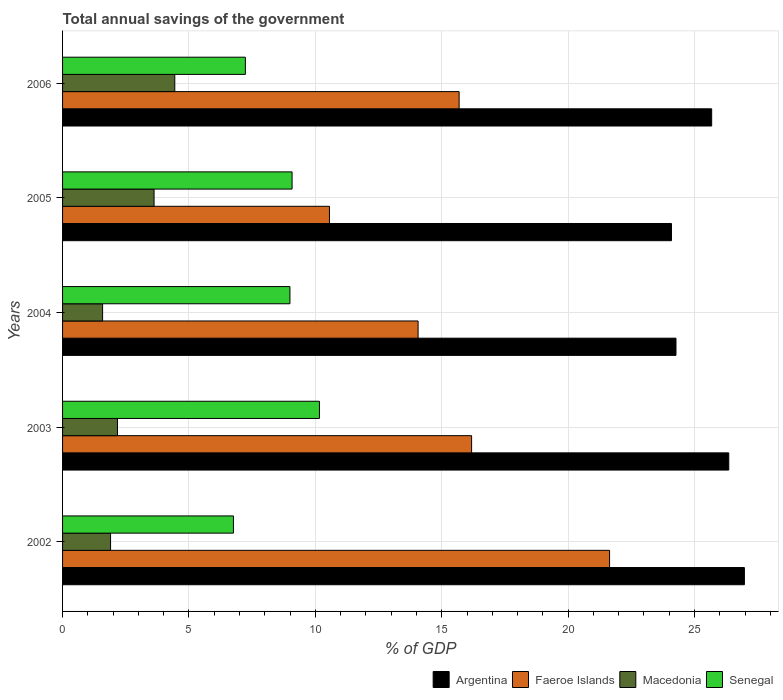Are the number of bars per tick equal to the number of legend labels?
Provide a succinct answer. Yes. How many bars are there on the 2nd tick from the bottom?
Your response must be concise. 4. What is the label of the 5th group of bars from the top?
Provide a short and direct response. 2002. What is the total annual savings of the government in Argentina in 2004?
Offer a terse response. 24.27. Across all years, what is the maximum total annual savings of the government in Senegal?
Provide a succinct answer. 10.16. Across all years, what is the minimum total annual savings of the government in Macedonia?
Ensure brevity in your answer.  1.58. What is the total total annual savings of the government in Macedonia in the graph?
Give a very brief answer. 13.71. What is the difference between the total annual savings of the government in Macedonia in 2004 and that in 2005?
Your response must be concise. -2.04. What is the difference between the total annual savings of the government in Senegal in 2003 and the total annual savings of the government in Argentina in 2002?
Provide a succinct answer. -16.81. What is the average total annual savings of the government in Argentina per year?
Give a very brief answer. 25.47. In the year 2004, what is the difference between the total annual savings of the government in Faeroe Islands and total annual savings of the government in Senegal?
Your answer should be compact. 5.07. In how many years, is the total annual savings of the government in Faeroe Islands greater than 11 %?
Provide a short and direct response. 4. What is the ratio of the total annual savings of the government in Macedonia in 2003 to that in 2005?
Give a very brief answer. 0.6. Is the total annual savings of the government in Macedonia in 2003 less than that in 2004?
Give a very brief answer. No. What is the difference between the highest and the second highest total annual savings of the government in Argentina?
Provide a succinct answer. 0.62. What is the difference between the highest and the lowest total annual savings of the government in Senegal?
Provide a succinct answer. 3.4. In how many years, is the total annual savings of the government in Macedonia greater than the average total annual savings of the government in Macedonia taken over all years?
Provide a short and direct response. 2. Is the sum of the total annual savings of the government in Argentina in 2004 and 2006 greater than the maximum total annual savings of the government in Faeroe Islands across all years?
Offer a terse response. Yes. Is it the case that in every year, the sum of the total annual savings of the government in Faeroe Islands and total annual savings of the government in Macedonia is greater than the sum of total annual savings of the government in Senegal and total annual savings of the government in Argentina?
Keep it short and to the point. No. What does the 3rd bar from the top in 2006 represents?
Provide a succinct answer. Faeroe Islands. What is the difference between two consecutive major ticks on the X-axis?
Give a very brief answer. 5. Are the values on the major ticks of X-axis written in scientific E-notation?
Your answer should be compact. No. Does the graph contain any zero values?
Give a very brief answer. No. Where does the legend appear in the graph?
Offer a terse response. Bottom right. What is the title of the graph?
Keep it short and to the point. Total annual savings of the government. Does "Germany" appear as one of the legend labels in the graph?
Provide a succinct answer. No. What is the label or title of the X-axis?
Offer a very short reply. % of GDP. What is the label or title of the Y-axis?
Your response must be concise. Years. What is the % of GDP of Argentina in 2002?
Your answer should be very brief. 26.97. What is the % of GDP in Faeroe Islands in 2002?
Offer a very short reply. 21.64. What is the % of GDP in Macedonia in 2002?
Give a very brief answer. 1.9. What is the % of GDP in Senegal in 2002?
Your answer should be very brief. 6.76. What is the % of GDP in Argentina in 2003?
Offer a terse response. 26.35. What is the % of GDP in Faeroe Islands in 2003?
Your answer should be compact. 16.18. What is the % of GDP of Macedonia in 2003?
Your answer should be compact. 2.17. What is the % of GDP of Senegal in 2003?
Offer a very short reply. 10.16. What is the % of GDP of Argentina in 2004?
Keep it short and to the point. 24.27. What is the % of GDP of Faeroe Islands in 2004?
Provide a succinct answer. 14.06. What is the % of GDP of Macedonia in 2004?
Offer a very short reply. 1.58. What is the % of GDP in Senegal in 2004?
Your response must be concise. 8.99. What is the % of GDP of Argentina in 2005?
Offer a very short reply. 24.09. What is the % of GDP in Faeroe Islands in 2005?
Make the answer very short. 10.56. What is the % of GDP in Macedonia in 2005?
Offer a very short reply. 3.62. What is the % of GDP of Senegal in 2005?
Provide a short and direct response. 9.08. What is the % of GDP of Argentina in 2006?
Ensure brevity in your answer.  25.68. What is the % of GDP in Faeroe Islands in 2006?
Offer a very short reply. 15.69. What is the % of GDP of Macedonia in 2006?
Ensure brevity in your answer.  4.44. What is the % of GDP in Senegal in 2006?
Your answer should be compact. 7.23. Across all years, what is the maximum % of GDP in Argentina?
Make the answer very short. 26.97. Across all years, what is the maximum % of GDP in Faeroe Islands?
Offer a very short reply. 21.64. Across all years, what is the maximum % of GDP in Macedonia?
Offer a very short reply. 4.44. Across all years, what is the maximum % of GDP of Senegal?
Make the answer very short. 10.16. Across all years, what is the minimum % of GDP in Argentina?
Your answer should be very brief. 24.09. Across all years, what is the minimum % of GDP in Faeroe Islands?
Provide a succinct answer. 10.56. Across all years, what is the minimum % of GDP of Macedonia?
Ensure brevity in your answer.  1.58. Across all years, what is the minimum % of GDP of Senegal?
Provide a succinct answer. 6.76. What is the total % of GDP in Argentina in the graph?
Make the answer very short. 127.36. What is the total % of GDP in Faeroe Islands in the graph?
Provide a succinct answer. 78.13. What is the total % of GDP in Macedonia in the graph?
Provide a short and direct response. 13.71. What is the total % of GDP of Senegal in the graph?
Make the answer very short. 42.23. What is the difference between the % of GDP in Argentina in 2002 and that in 2003?
Provide a succinct answer. 0.62. What is the difference between the % of GDP in Faeroe Islands in 2002 and that in 2003?
Offer a very short reply. 5.46. What is the difference between the % of GDP of Macedonia in 2002 and that in 2003?
Your answer should be compact. -0.27. What is the difference between the % of GDP of Senegal in 2002 and that in 2003?
Your answer should be compact. -3.4. What is the difference between the % of GDP of Argentina in 2002 and that in 2004?
Offer a very short reply. 2.71. What is the difference between the % of GDP in Faeroe Islands in 2002 and that in 2004?
Offer a very short reply. 7.57. What is the difference between the % of GDP in Macedonia in 2002 and that in 2004?
Ensure brevity in your answer.  0.32. What is the difference between the % of GDP of Senegal in 2002 and that in 2004?
Give a very brief answer. -2.24. What is the difference between the % of GDP in Argentina in 2002 and that in 2005?
Give a very brief answer. 2.88. What is the difference between the % of GDP of Faeroe Islands in 2002 and that in 2005?
Your answer should be compact. 11.08. What is the difference between the % of GDP of Macedonia in 2002 and that in 2005?
Keep it short and to the point. -1.72. What is the difference between the % of GDP in Senegal in 2002 and that in 2005?
Your response must be concise. -2.32. What is the difference between the % of GDP of Argentina in 2002 and that in 2006?
Give a very brief answer. 1.29. What is the difference between the % of GDP in Faeroe Islands in 2002 and that in 2006?
Ensure brevity in your answer.  5.95. What is the difference between the % of GDP in Macedonia in 2002 and that in 2006?
Your response must be concise. -2.54. What is the difference between the % of GDP in Senegal in 2002 and that in 2006?
Offer a terse response. -0.47. What is the difference between the % of GDP of Argentina in 2003 and that in 2004?
Provide a succinct answer. 2.09. What is the difference between the % of GDP in Faeroe Islands in 2003 and that in 2004?
Your answer should be very brief. 2.12. What is the difference between the % of GDP of Macedonia in 2003 and that in 2004?
Your answer should be very brief. 0.59. What is the difference between the % of GDP in Senegal in 2003 and that in 2004?
Make the answer very short. 1.17. What is the difference between the % of GDP in Argentina in 2003 and that in 2005?
Your answer should be compact. 2.27. What is the difference between the % of GDP in Faeroe Islands in 2003 and that in 2005?
Give a very brief answer. 5.62. What is the difference between the % of GDP of Macedonia in 2003 and that in 2005?
Provide a short and direct response. -1.45. What is the difference between the % of GDP in Senegal in 2003 and that in 2005?
Keep it short and to the point. 1.08. What is the difference between the % of GDP in Argentina in 2003 and that in 2006?
Your response must be concise. 0.68. What is the difference between the % of GDP in Faeroe Islands in 2003 and that in 2006?
Your answer should be very brief. 0.49. What is the difference between the % of GDP of Macedonia in 2003 and that in 2006?
Ensure brevity in your answer.  -2.27. What is the difference between the % of GDP in Senegal in 2003 and that in 2006?
Give a very brief answer. 2.93. What is the difference between the % of GDP of Argentina in 2004 and that in 2005?
Offer a terse response. 0.18. What is the difference between the % of GDP of Faeroe Islands in 2004 and that in 2005?
Provide a succinct answer. 3.51. What is the difference between the % of GDP in Macedonia in 2004 and that in 2005?
Your answer should be very brief. -2.04. What is the difference between the % of GDP of Senegal in 2004 and that in 2005?
Give a very brief answer. -0.08. What is the difference between the % of GDP of Argentina in 2004 and that in 2006?
Your answer should be very brief. -1.41. What is the difference between the % of GDP in Faeroe Islands in 2004 and that in 2006?
Offer a very short reply. -1.62. What is the difference between the % of GDP in Macedonia in 2004 and that in 2006?
Provide a succinct answer. -2.86. What is the difference between the % of GDP in Senegal in 2004 and that in 2006?
Keep it short and to the point. 1.76. What is the difference between the % of GDP of Argentina in 2005 and that in 2006?
Offer a terse response. -1.59. What is the difference between the % of GDP of Faeroe Islands in 2005 and that in 2006?
Offer a terse response. -5.13. What is the difference between the % of GDP in Macedonia in 2005 and that in 2006?
Keep it short and to the point. -0.82. What is the difference between the % of GDP in Senegal in 2005 and that in 2006?
Offer a terse response. 1.85. What is the difference between the % of GDP in Argentina in 2002 and the % of GDP in Faeroe Islands in 2003?
Ensure brevity in your answer.  10.79. What is the difference between the % of GDP in Argentina in 2002 and the % of GDP in Macedonia in 2003?
Keep it short and to the point. 24.8. What is the difference between the % of GDP of Argentina in 2002 and the % of GDP of Senegal in 2003?
Ensure brevity in your answer.  16.81. What is the difference between the % of GDP in Faeroe Islands in 2002 and the % of GDP in Macedonia in 2003?
Provide a short and direct response. 19.47. What is the difference between the % of GDP of Faeroe Islands in 2002 and the % of GDP of Senegal in 2003?
Offer a terse response. 11.48. What is the difference between the % of GDP in Macedonia in 2002 and the % of GDP in Senegal in 2003?
Keep it short and to the point. -8.26. What is the difference between the % of GDP of Argentina in 2002 and the % of GDP of Faeroe Islands in 2004?
Keep it short and to the point. 12.91. What is the difference between the % of GDP in Argentina in 2002 and the % of GDP in Macedonia in 2004?
Your response must be concise. 25.39. What is the difference between the % of GDP in Argentina in 2002 and the % of GDP in Senegal in 2004?
Offer a terse response. 17.98. What is the difference between the % of GDP in Faeroe Islands in 2002 and the % of GDP in Macedonia in 2004?
Offer a very short reply. 20.06. What is the difference between the % of GDP in Faeroe Islands in 2002 and the % of GDP in Senegal in 2004?
Your response must be concise. 12.64. What is the difference between the % of GDP in Macedonia in 2002 and the % of GDP in Senegal in 2004?
Provide a succinct answer. -7.1. What is the difference between the % of GDP in Argentina in 2002 and the % of GDP in Faeroe Islands in 2005?
Ensure brevity in your answer.  16.41. What is the difference between the % of GDP of Argentina in 2002 and the % of GDP of Macedonia in 2005?
Your answer should be very brief. 23.35. What is the difference between the % of GDP of Argentina in 2002 and the % of GDP of Senegal in 2005?
Offer a very short reply. 17.89. What is the difference between the % of GDP of Faeroe Islands in 2002 and the % of GDP of Macedonia in 2005?
Offer a very short reply. 18.02. What is the difference between the % of GDP in Faeroe Islands in 2002 and the % of GDP in Senegal in 2005?
Offer a terse response. 12.56. What is the difference between the % of GDP in Macedonia in 2002 and the % of GDP in Senegal in 2005?
Your answer should be very brief. -7.18. What is the difference between the % of GDP of Argentina in 2002 and the % of GDP of Faeroe Islands in 2006?
Your answer should be compact. 11.29. What is the difference between the % of GDP in Argentina in 2002 and the % of GDP in Macedonia in 2006?
Keep it short and to the point. 22.53. What is the difference between the % of GDP in Argentina in 2002 and the % of GDP in Senegal in 2006?
Provide a short and direct response. 19.74. What is the difference between the % of GDP of Faeroe Islands in 2002 and the % of GDP of Macedonia in 2006?
Provide a short and direct response. 17.2. What is the difference between the % of GDP of Faeroe Islands in 2002 and the % of GDP of Senegal in 2006?
Ensure brevity in your answer.  14.41. What is the difference between the % of GDP in Macedonia in 2002 and the % of GDP in Senegal in 2006?
Provide a succinct answer. -5.33. What is the difference between the % of GDP in Argentina in 2003 and the % of GDP in Faeroe Islands in 2004?
Your answer should be compact. 12.29. What is the difference between the % of GDP in Argentina in 2003 and the % of GDP in Macedonia in 2004?
Provide a succinct answer. 24.77. What is the difference between the % of GDP in Argentina in 2003 and the % of GDP in Senegal in 2004?
Your response must be concise. 17.36. What is the difference between the % of GDP of Faeroe Islands in 2003 and the % of GDP of Macedonia in 2004?
Your answer should be compact. 14.6. What is the difference between the % of GDP in Faeroe Islands in 2003 and the % of GDP in Senegal in 2004?
Your answer should be very brief. 7.19. What is the difference between the % of GDP in Macedonia in 2003 and the % of GDP in Senegal in 2004?
Make the answer very short. -6.82. What is the difference between the % of GDP in Argentina in 2003 and the % of GDP in Faeroe Islands in 2005?
Ensure brevity in your answer.  15.8. What is the difference between the % of GDP of Argentina in 2003 and the % of GDP of Macedonia in 2005?
Offer a very short reply. 22.74. What is the difference between the % of GDP of Argentina in 2003 and the % of GDP of Senegal in 2005?
Provide a short and direct response. 17.28. What is the difference between the % of GDP of Faeroe Islands in 2003 and the % of GDP of Macedonia in 2005?
Provide a short and direct response. 12.56. What is the difference between the % of GDP of Faeroe Islands in 2003 and the % of GDP of Senegal in 2005?
Your answer should be very brief. 7.1. What is the difference between the % of GDP of Macedonia in 2003 and the % of GDP of Senegal in 2005?
Provide a succinct answer. -6.91. What is the difference between the % of GDP in Argentina in 2003 and the % of GDP in Faeroe Islands in 2006?
Provide a short and direct response. 10.67. What is the difference between the % of GDP in Argentina in 2003 and the % of GDP in Macedonia in 2006?
Provide a short and direct response. 21.92. What is the difference between the % of GDP of Argentina in 2003 and the % of GDP of Senegal in 2006?
Your answer should be compact. 19.12. What is the difference between the % of GDP in Faeroe Islands in 2003 and the % of GDP in Macedonia in 2006?
Your response must be concise. 11.74. What is the difference between the % of GDP of Faeroe Islands in 2003 and the % of GDP of Senegal in 2006?
Your answer should be very brief. 8.95. What is the difference between the % of GDP in Macedonia in 2003 and the % of GDP in Senegal in 2006?
Provide a short and direct response. -5.06. What is the difference between the % of GDP of Argentina in 2004 and the % of GDP of Faeroe Islands in 2005?
Make the answer very short. 13.71. What is the difference between the % of GDP of Argentina in 2004 and the % of GDP of Macedonia in 2005?
Ensure brevity in your answer.  20.65. What is the difference between the % of GDP of Argentina in 2004 and the % of GDP of Senegal in 2005?
Make the answer very short. 15.19. What is the difference between the % of GDP of Faeroe Islands in 2004 and the % of GDP of Macedonia in 2005?
Your answer should be very brief. 10.45. What is the difference between the % of GDP of Faeroe Islands in 2004 and the % of GDP of Senegal in 2005?
Make the answer very short. 4.99. What is the difference between the % of GDP in Macedonia in 2004 and the % of GDP in Senegal in 2005?
Offer a very short reply. -7.5. What is the difference between the % of GDP in Argentina in 2004 and the % of GDP in Faeroe Islands in 2006?
Keep it short and to the point. 8.58. What is the difference between the % of GDP in Argentina in 2004 and the % of GDP in Macedonia in 2006?
Provide a succinct answer. 19.83. What is the difference between the % of GDP of Argentina in 2004 and the % of GDP of Senegal in 2006?
Ensure brevity in your answer.  17.03. What is the difference between the % of GDP of Faeroe Islands in 2004 and the % of GDP of Macedonia in 2006?
Your answer should be compact. 9.63. What is the difference between the % of GDP of Faeroe Islands in 2004 and the % of GDP of Senegal in 2006?
Your response must be concise. 6.83. What is the difference between the % of GDP of Macedonia in 2004 and the % of GDP of Senegal in 2006?
Offer a very short reply. -5.65. What is the difference between the % of GDP in Argentina in 2005 and the % of GDP in Faeroe Islands in 2006?
Offer a very short reply. 8.4. What is the difference between the % of GDP in Argentina in 2005 and the % of GDP in Macedonia in 2006?
Your response must be concise. 19.65. What is the difference between the % of GDP of Argentina in 2005 and the % of GDP of Senegal in 2006?
Keep it short and to the point. 16.86. What is the difference between the % of GDP in Faeroe Islands in 2005 and the % of GDP in Macedonia in 2006?
Give a very brief answer. 6.12. What is the difference between the % of GDP of Faeroe Islands in 2005 and the % of GDP of Senegal in 2006?
Make the answer very short. 3.33. What is the difference between the % of GDP of Macedonia in 2005 and the % of GDP of Senegal in 2006?
Your answer should be compact. -3.61. What is the average % of GDP of Argentina per year?
Provide a succinct answer. 25.47. What is the average % of GDP of Faeroe Islands per year?
Give a very brief answer. 15.63. What is the average % of GDP of Macedonia per year?
Your answer should be compact. 2.74. What is the average % of GDP of Senegal per year?
Your answer should be compact. 8.45. In the year 2002, what is the difference between the % of GDP in Argentina and % of GDP in Faeroe Islands?
Offer a very short reply. 5.33. In the year 2002, what is the difference between the % of GDP in Argentina and % of GDP in Macedonia?
Make the answer very short. 25.07. In the year 2002, what is the difference between the % of GDP of Argentina and % of GDP of Senegal?
Offer a very short reply. 20.21. In the year 2002, what is the difference between the % of GDP in Faeroe Islands and % of GDP in Macedonia?
Give a very brief answer. 19.74. In the year 2002, what is the difference between the % of GDP in Faeroe Islands and % of GDP in Senegal?
Offer a terse response. 14.88. In the year 2002, what is the difference between the % of GDP of Macedonia and % of GDP of Senegal?
Ensure brevity in your answer.  -4.86. In the year 2003, what is the difference between the % of GDP in Argentina and % of GDP in Faeroe Islands?
Ensure brevity in your answer.  10.17. In the year 2003, what is the difference between the % of GDP in Argentina and % of GDP in Macedonia?
Your response must be concise. 24.18. In the year 2003, what is the difference between the % of GDP in Argentina and % of GDP in Senegal?
Your answer should be compact. 16.19. In the year 2003, what is the difference between the % of GDP of Faeroe Islands and % of GDP of Macedonia?
Provide a short and direct response. 14.01. In the year 2003, what is the difference between the % of GDP in Faeroe Islands and % of GDP in Senegal?
Offer a very short reply. 6.02. In the year 2003, what is the difference between the % of GDP of Macedonia and % of GDP of Senegal?
Your answer should be very brief. -7.99. In the year 2004, what is the difference between the % of GDP of Argentina and % of GDP of Faeroe Islands?
Offer a very short reply. 10.2. In the year 2004, what is the difference between the % of GDP of Argentina and % of GDP of Macedonia?
Ensure brevity in your answer.  22.68. In the year 2004, what is the difference between the % of GDP in Argentina and % of GDP in Senegal?
Provide a short and direct response. 15.27. In the year 2004, what is the difference between the % of GDP in Faeroe Islands and % of GDP in Macedonia?
Give a very brief answer. 12.48. In the year 2004, what is the difference between the % of GDP in Faeroe Islands and % of GDP in Senegal?
Your answer should be compact. 5.07. In the year 2004, what is the difference between the % of GDP in Macedonia and % of GDP in Senegal?
Your answer should be compact. -7.41. In the year 2005, what is the difference between the % of GDP of Argentina and % of GDP of Faeroe Islands?
Provide a short and direct response. 13.53. In the year 2005, what is the difference between the % of GDP in Argentina and % of GDP in Macedonia?
Your response must be concise. 20.47. In the year 2005, what is the difference between the % of GDP in Argentina and % of GDP in Senegal?
Your answer should be very brief. 15.01. In the year 2005, what is the difference between the % of GDP of Faeroe Islands and % of GDP of Macedonia?
Your response must be concise. 6.94. In the year 2005, what is the difference between the % of GDP in Faeroe Islands and % of GDP in Senegal?
Offer a terse response. 1.48. In the year 2005, what is the difference between the % of GDP in Macedonia and % of GDP in Senegal?
Provide a short and direct response. -5.46. In the year 2006, what is the difference between the % of GDP of Argentina and % of GDP of Faeroe Islands?
Provide a succinct answer. 9.99. In the year 2006, what is the difference between the % of GDP in Argentina and % of GDP in Macedonia?
Provide a succinct answer. 21.24. In the year 2006, what is the difference between the % of GDP of Argentina and % of GDP of Senegal?
Keep it short and to the point. 18.45. In the year 2006, what is the difference between the % of GDP in Faeroe Islands and % of GDP in Macedonia?
Offer a very short reply. 11.25. In the year 2006, what is the difference between the % of GDP in Faeroe Islands and % of GDP in Senegal?
Give a very brief answer. 8.46. In the year 2006, what is the difference between the % of GDP in Macedonia and % of GDP in Senegal?
Provide a succinct answer. -2.79. What is the ratio of the % of GDP in Argentina in 2002 to that in 2003?
Offer a very short reply. 1.02. What is the ratio of the % of GDP of Faeroe Islands in 2002 to that in 2003?
Provide a short and direct response. 1.34. What is the ratio of the % of GDP of Macedonia in 2002 to that in 2003?
Give a very brief answer. 0.87. What is the ratio of the % of GDP in Senegal in 2002 to that in 2003?
Give a very brief answer. 0.67. What is the ratio of the % of GDP in Argentina in 2002 to that in 2004?
Provide a short and direct response. 1.11. What is the ratio of the % of GDP of Faeroe Islands in 2002 to that in 2004?
Make the answer very short. 1.54. What is the ratio of the % of GDP in Macedonia in 2002 to that in 2004?
Your response must be concise. 1.2. What is the ratio of the % of GDP in Senegal in 2002 to that in 2004?
Make the answer very short. 0.75. What is the ratio of the % of GDP in Argentina in 2002 to that in 2005?
Give a very brief answer. 1.12. What is the ratio of the % of GDP in Faeroe Islands in 2002 to that in 2005?
Provide a succinct answer. 2.05. What is the ratio of the % of GDP of Macedonia in 2002 to that in 2005?
Keep it short and to the point. 0.52. What is the ratio of the % of GDP in Senegal in 2002 to that in 2005?
Offer a very short reply. 0.74. What is the ratio of the % of GDP in Argentina in 2002 to that in 2006?
Your answer should be very brief. 1.05. What is the ratio of the % of GDP in Faeroe Islands in 2002 to that in 2006?
Your answer should be compact. 1.38. What is the ratio of the % of GDP in Macedonia in 2002 to that in 2006?
Your answer should be very brief. 0.43. What is the ratio of the % of GDP of Senegal in 2002 to that in 2006?
Provide a succinct answer. 0.93. What is the ratio of the % of GDP in Argentina in 2003 to that in 2004?
Ensure brevity in your answer.  1.09. What is the ratio of the % of GDP of Faeroe Islands in 2003 to that in 2004?
Your answer should be compact. 1.15. What is the ratio of the % of GDP of Macedonia in 2003 to that in 2004?
Provide a short and direct response. 1.37. What is the ratio of the % of GDP in Senegal in 2003 to that in 2004?
Give a very brief answer. 1.13. What is the ratio of the % of GDP in Argentina in 2003 to that in 2005?
Give a very brief answer. 1.09. What is the ratio of the % of GDP of Faeroe Islands in 2003 to that in 2005?
Your answer should be very brief. 1.53. What is the ratio of the % of GDP of Macedonia in 2003 to that in 2005?
Give a very brief answer. 0.6. What is the ratio of the % of GDP in Senegal in 2003 to that in 2005?
Ensure brevity in your answer.  1.12. What is the ratio of the % of GDP in Argentina in 2003 to that in 2006?
Your answer should be very brief. 1.03. What is the ratio of the % of GDP of Faeroe Islands in 2003 to that in 2006?
Give a very brief answer. 1.03. What is the ratio of the % of GDP of Macedonia in 2003 to that in 2006?
Your response must be concise. 0.49. What is the ratio of the % of GDP in Senegal in 2003 to that in 2006?
Provide a short and direct response. 1.41. What is the ratio of the % of GDP of Argentina in 2004 to that in 2005?
Offer a very short reply. 1.01. What is the ratio of the % of GDP in Faeroe Islands in 2004 to that in 2005?
Your response must be concise. 1.33. What is the ratio of the % of GDP in Macedonia in 2004 to that in 2005?
Your answer should be very brief. 0.44. What is the ratio of the % of GDP of Argentina in 2004 to that in 2006?
Provide a short and direct response. 0.94. What is the ratio of the % of GDP of Faeroe Islands in 2004 to that in 2006?
Keep it short and to the point. 0.9. What is the ratio of the % of GDP of Macedonia in 2004 to that in 2006?
Provide a short and direct response. 0.36. What is the ratio of the % of GDP of Senegal in 2004 to that in 2006?
Provide a short and direct response. 1.24. What is the ratio of the % of GDP of Argentina in 2005 to that in 2006?
Your answer should be very brief. 0.94. What is the ratio of the % of GDP of Faeroe Islands in 2005 to that in 2006?
Your response must be concise. 0.67. What is the ratio of the % of GDP in Macedonia in 2005 to that in 2006?
Your response must be concise. 0.82. What is the ratio of the % of GDP of Senegal in 2005 to that in 2006?
Make the answer very short. 1.26. What is the difference between the highest and the second highest % of GDP of Argentina?
Offer a terse response. 0.62. What is the difference between the highest and the second highest % of GDP in Faeroe Islands?
Give a very brief answer. 5.46. What is the difference between the highest and the second highest % of GDP in Macedonia?
Your answer should be very brief. 0.82. What is the difference between the highest and the second highest % of GDP in Senegal?
Ensure brevity in your answer.  1.08. What is the difference between the highest and the lowest % of GDP in Argentina?
Ensure brevity in your answer.  2.88. What is the difference between the highest and the lowest % of GDP in Faeroe Islands?
Keep it short and to the point. 11.08. What is the difference between the highest and the lowest % of GDP of Macedonia?
Give a very brief answer. 2.86. What is the difference between the highest and the lowest % of GDP in Senegal?
Provide a short and direct response. 3.4. 